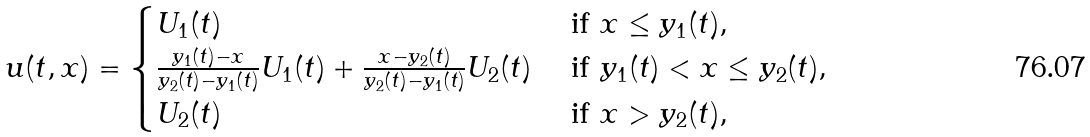<formula> <loc_0><loc_0><loc_500><loc_500>u ( t , x ) = \begin{cases} U _ { 1 } ( t ) & \text { if } x \leq y _ { 1 } ( t ) , \\ \frac { y _ { 1 } ( t ) - x } { y _ { 2 } ( t ) - y _ { 1 } ( t ) } U _ { 1 } ( t ) + \frac { x - y _ { 2 } ( t ) } { y _ { 2 } ( t ) - y _ { 1 } ( t ) } U _ { 2 } ( t ) & \text { if } y _ { 1 } ( t ) < x \leq y _ { 2 } ( t ) , \\ U _ { 2 } ( t ) & \text { if } x > y _ { 2 } ( t ) , \\ \end{cases}</formula> 